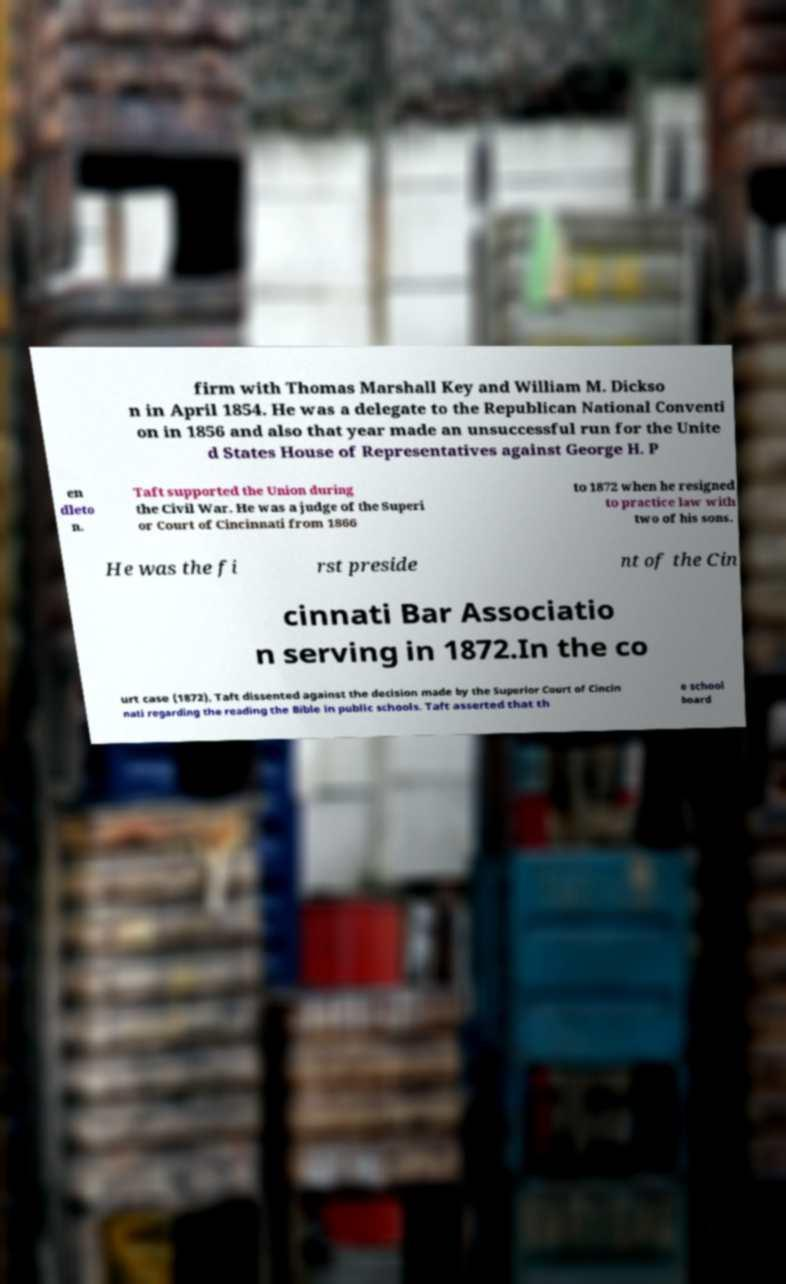I need the written content from this picture converted into text. Can you do that? firm with Thomas Marshall Key and William M. Dickso n in April 1854. He was a delegate to the Republican National Conventi on in 1856 and also that year made an unsuccessful run for the Unite d States House of Representatives against George H. P en dleto n. Taft supported the Union during the Civil War. He was a judge of the Superi or Court of Cincinnati from 1866 to 1872 when he resigned to practice law with two of his sons. He was the fi rst preside nt of the Cin cinnati Bar Associatio n serving in 1872.In the co urt case (1872), Taft dissented against the decision made by the Superior Court of Cincin nati regarding the reading the Bible in public schools. Taft asserted that th e school board 